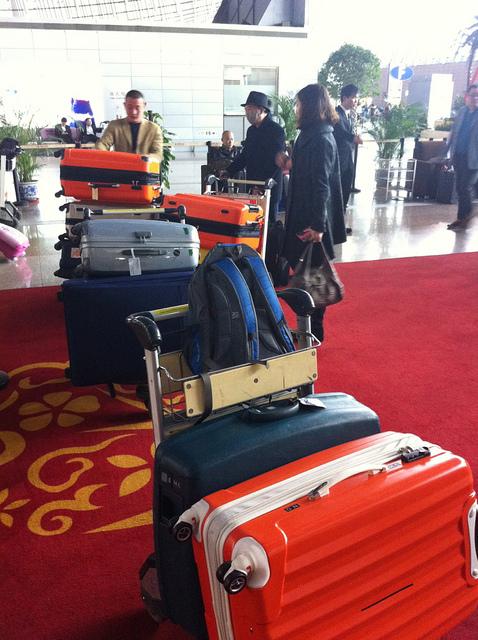Where is the blue backpack?
Be succinct. Cart. Which airport is this?
Concise answer only. Lax. Is this an airport?
Short answer required. Yes. 